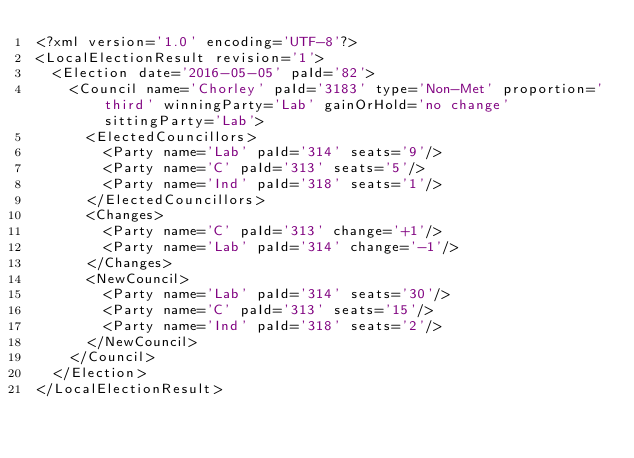<code> <loc_0><loc_0><loc_500><loc_500><_XML_><?xml version='1.0' encoding='UTF-8'?>
<LocalElectionResult revision='1'>
  <Election date='2016-05-05' paId='82'>
    <Council name='Chorley' paId='3183' type='Non-Met' proportion='third' winningParty='Lab' gainOrHold='no change' sittingParty='Lab'>
      <ElectedCouncillors>
        <Party name='Lab' paId='314' seats='9'/>
        <Party name='C' paId='313' seats='5'/>
        <Party name='Ind' paId='318' seats='1'/>
      </ElectedCouncillors>
      <Changes>
        <Party name='C' paId='313' change='+1'/>
        <Party name='Lab' paId='314' change='-1'/>
      </Changes>
      <NewCouncil>
        <Party name='Lab' paId='314' seats='30'/>
        <Party name='C' paId='313' seats='15'/>
        <Party name='Ind' paId='318' seats='2'/>
      </NewCouncil>
    </Council>
  </Election>
</LocalElectionResult></code> 